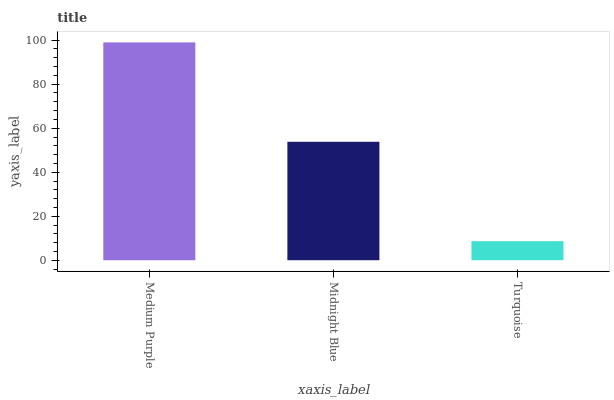Is Turquoise the minimum?
Answer yes or no. Yes. Is Medium Purple the maximum?
Answer yes or no. Yes. Is Midnight Blue the minimum?
Answer yes or no. No. Is Midnight Blue the maximum?
Answer yes or no. No. Is Medium Purple greater than Midnight Blue?
Answer yes or no. Yes. Is Midnight Blue less than Medium Purple?
Answer yes or no. Yes. Is Midnight Blue greater than Medium Purple?
Answer yes or no. No. Is Medium Purple less than Midnight Blue?
Answer yes or no. No. Is Midnight Blue the high median?
Answer yes or no. Yes. Is Midnight Blue the low median?
Answer yes or no. Yes. Is Medium Purple the high median?
Answer yes or no. No. Is Medium Purple the low median?
Answer yes or no. No. 